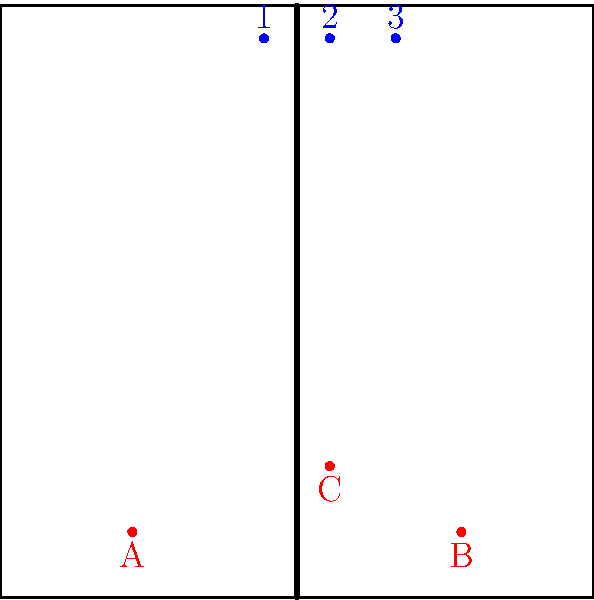Given the attacking formation shown in the diagram, where attackers A and B are in the front corners and C is in the middle, what is the optimal blocking formation for defenders 1, 2, and 3 to maximize coverage against a quick attack from position C? To determine the optimal blocking formation, we need to consider the following factors:

1. The position of the attackers: A (left front), B (right front), and C (middle front).
2. The quick attack is coming from position C, which is the most immediate threat.
3. The blockers need to cover as much court area as possible while prioritizing the quick attack.

Step-by-step analysis:

1. Blocker 2 should be positioned directly in front of attacker C to counter the quick attack. This is the primary defensive priority.

2. Blockers 1 and 3 need to be positioned to assist blocker 2 while also being ready to shift towards attackers A and B if necessary.

3. The optimal formation would be a bunch block, where all three blockers are close together, slightly favoring the middle of the court:
   - Blocker 1 should move slightly to the right, closer to blocker 2.
   - Blocker 2 stays in the middle, directly opposite attacker C.
   - Blocker 3 should move slightly to the left, closer to blocker 2.

4. This formation allows for:
   a) A strong triple block against the quick attack from C.
   b) Quick adjustment to form a double block on either side if the set goes to A or B.
   c) Maximum court coverage with minimal gaps between blockers.

5. The slight favoring of the middle also accounts for the fact that cross-court attacks are statistically more common than line shots.

This formation, known as a "bunch block" or "stack block," was often employed by teams coached by Lang Ping, especially when facing opponents with strong middle attackers.
Answer: Bunch block 